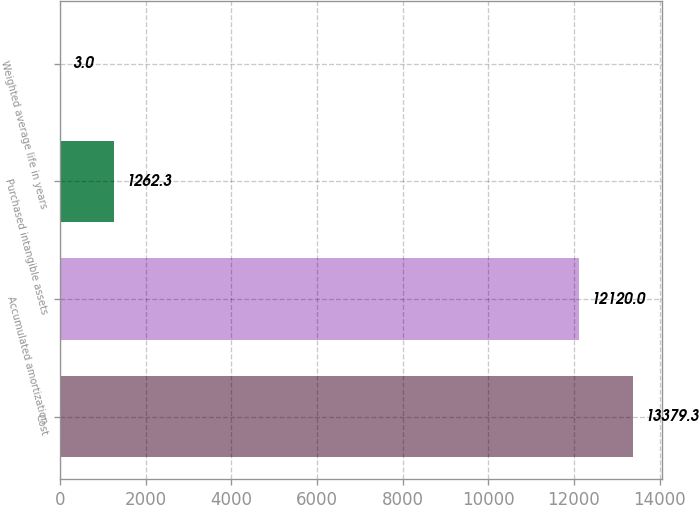Convert chart. <chart><loc_0><loc_0><loc_500><loc_500><bar_chart><fcel>Cost<fcel>Accumulated amortization<fcel>Purchased intangible assets<fcel>Weighted average life in years<nl><fcel>13379.3<fcel>12120<fcel>1262.3<fcel>3<nl></chart> 